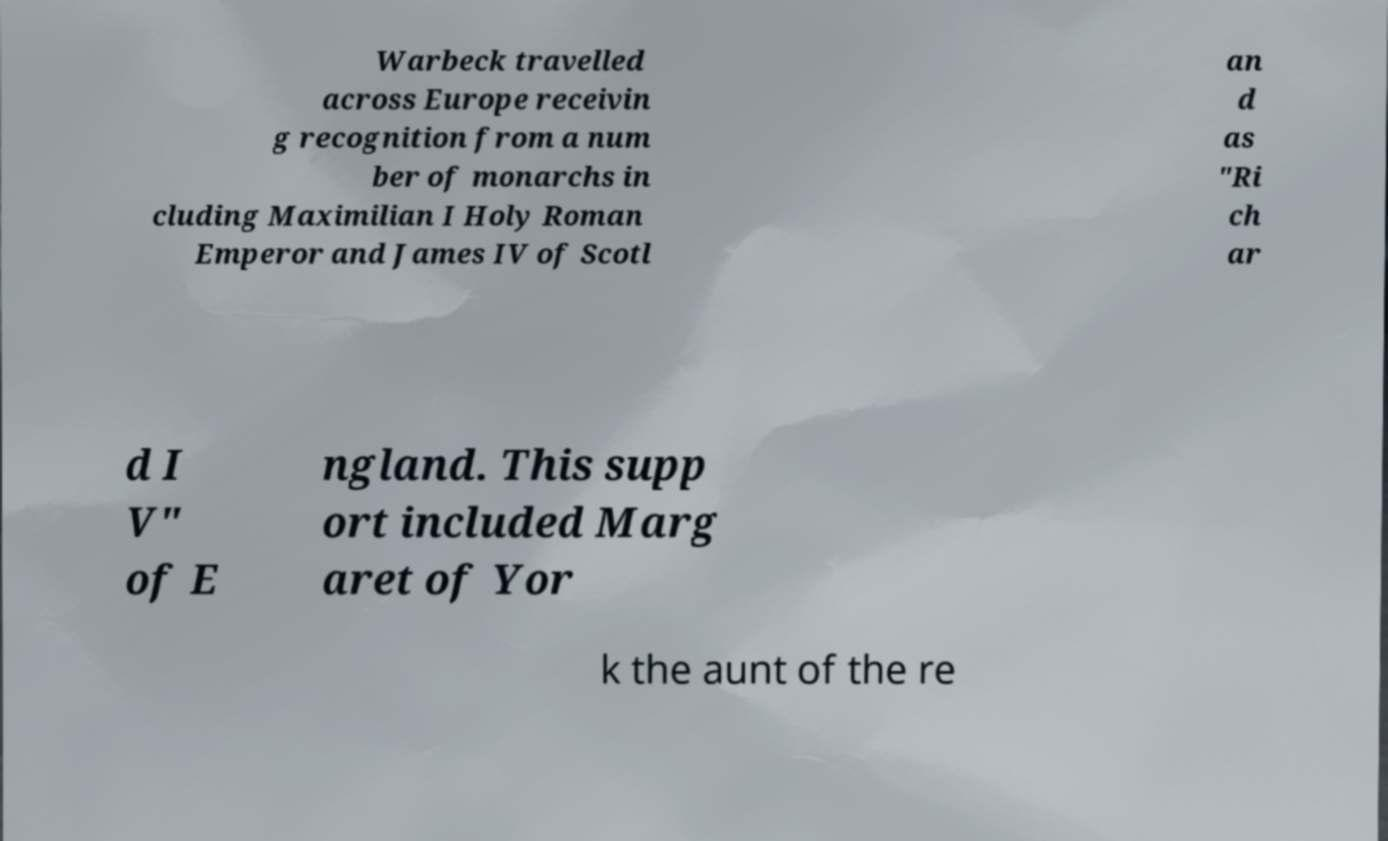Please identify and transcribe the text found in this image. Warbeck travelled across Europe receivin g recognition from a num ber of monarchs in cluding Maximilian I Holy Roman Emperor and James IV of Scotl an d as "Ri ch ar d I V" of E ngland. This supp ort included Marg aret of Yor k the aunt of the re 